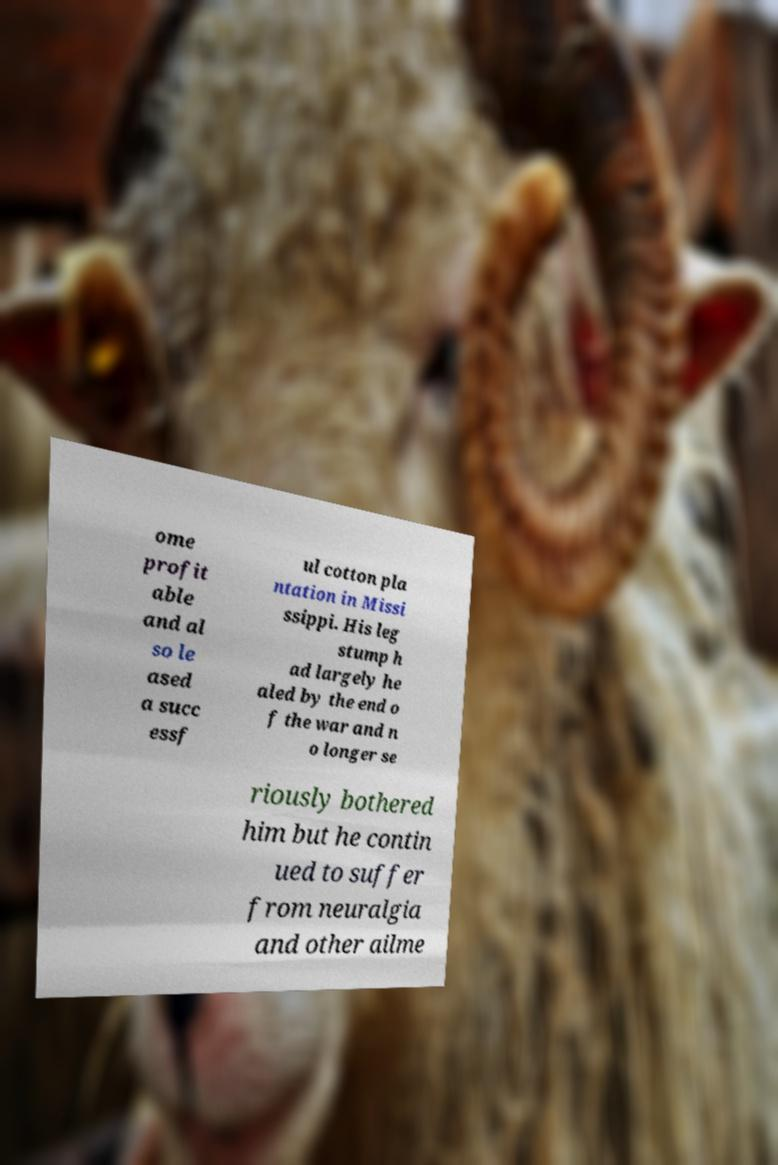Can you accurately transcribe the text from the provided image for me? ome profit able and al so le ased a succ essf ul cotton pla ntation in Missi ssippi. His leg stump h ad largely he aled by the end o f the war and n o longer se riously bothered him but he contin ued to suffer from neuralgia and other ailme 